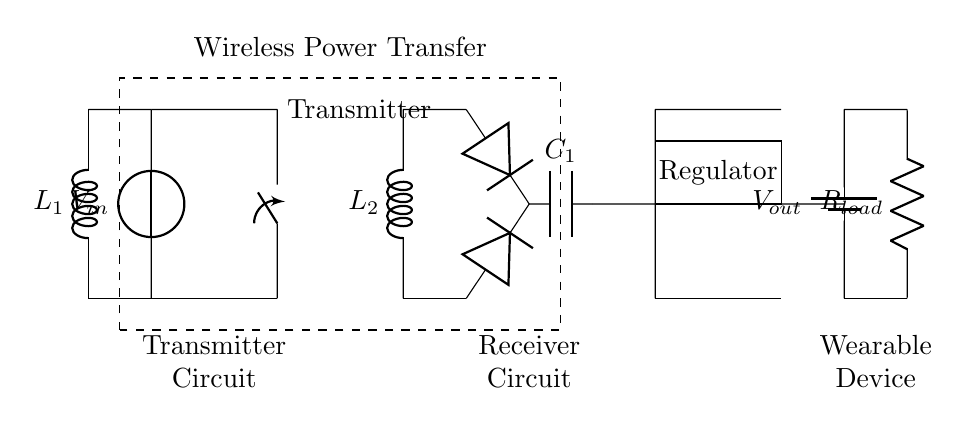What type of circuit is depicted? The diagram shows a wireless charging circuit consisting of a transmitter and a receiver. The transmitter is represented on the left with a coil and circuit components, and the receiver is on the right with a rectifier and regulator.
Answer: wireless charging What is the role of the diode in the circuit? The diodes in the circuit serve as rectifiers, allowing current to flow in one direction and converting alternating current (from the receiver coil) to direct current for the output.
Answer: rectification What component regulates the output voltage? The voltage regulator, represented by a rectangle labeled "Regulator," is responsible for maintaining a stable output voltage to the wearable device.
Answer: regulator How many coils are present in the circuit? There are two coils present; a transmitter coil labeled L1 and a receiver coil labeled L2, each serving a different function in wireless power transfer.
Answer: two What is the purpose of the capacitor? The capacitor labeled C1 is used for smoothing the rectified current, reducing voltage fluctuations and providing a stable power supply to the load.
Answer: smoothing What is the load resistance value labeled in the circuit? The resistance in the load is labeled R_load, which indicates the component that the output voltage is applied to; this is typically a variable value depending on the device.
Answer: R_load What type of power transfer does this circuit employ? This circuit utilizes inductive coupling for power transfer, where energy is wirelessly transferred between the transmitter and receiver coils through a magnetic field.
Answer: inductive coupling 